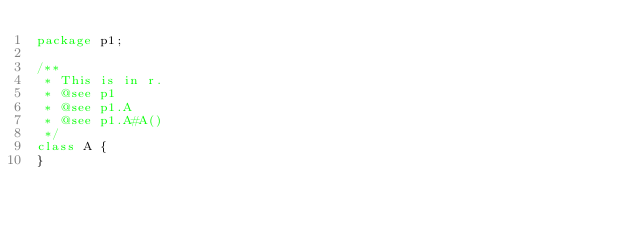<code> <loc_0><loc_0><loc_500><loc_500><_Java_>package p1;

/**
 * This is in r.
 * @see p1
 * @see p1.A
 * @see p1.A#A()
 */
class A {
}
</code> 